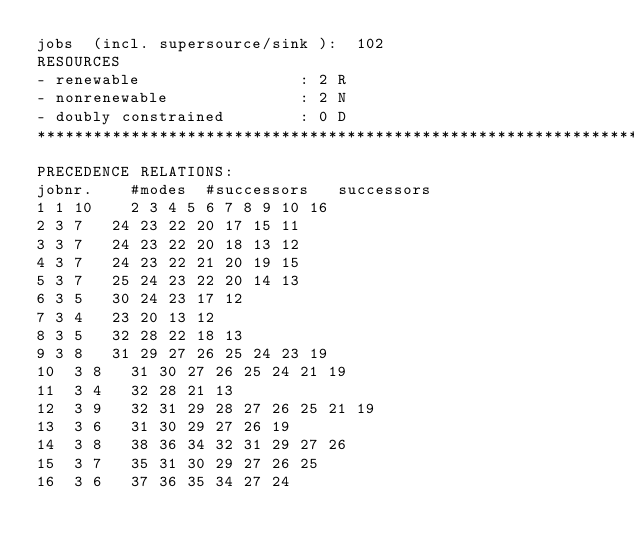Convert code to text. <code><loc_0><loc_0><loc_500><loc_500><_ObjectiveC_>jobs  (incl. supersource/sink ):	102
RESOURCES
- renewable                 : 2 R
- nonrenewable              : 2 N
- doubly constrained        : 0 D
************************************************************************
PRECEDENCE RELATIONS:
jobnr.    #modes  #successors   successors
1	1	10		2 3 4 5 6 7 8 9 10 16 
2	3	7		24 23 22 20 17 15 11 
3	3	7		24 23 22 20 18 13 12 
4	3	7		24 23 22 21 20 19 15 
5	3	7		25 24 23 22 20 14 13 
6	3	5		30 24 23 17 12 
7	3	4		23 20 13 12 
8	3	5		32 28 22 18 13 
9	3	8		31 29 27 26 25 24 23 19 
10	3	8		31 30 27 26 25 24 21 19 
11	3	4		32 28 21 13 
12	3	9		32 31 29 28 27 26 25 21 19 
13	3	6		31 30 29 27 26 19 
14	3	8		38 36 34 32 31 29 27 26 
15	3	7		35 31 30 29 27 26 25 
16	3	6		37 36 35 34 27 24 </code> 